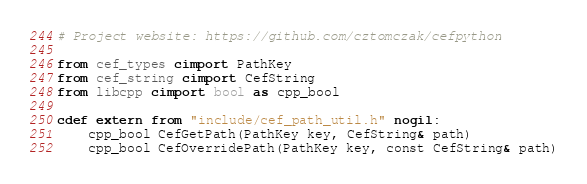<code> <loc_0><loc_0><loc_500><loc_500><_Cython_># Project website: https://github.com/cztomczak/cefpython

from cef_types cimport PathKey
from cef_string cimport CefString
from libcpp cimport bool as cpp_bool

cdef extern from "include/cef_path_util.h" nogil:
    cpp_bool CefGetPath(PathKey key, CefString& path)
    cpp_bool CefOverridePath(PathKey key, const CefString& path)
</code> 